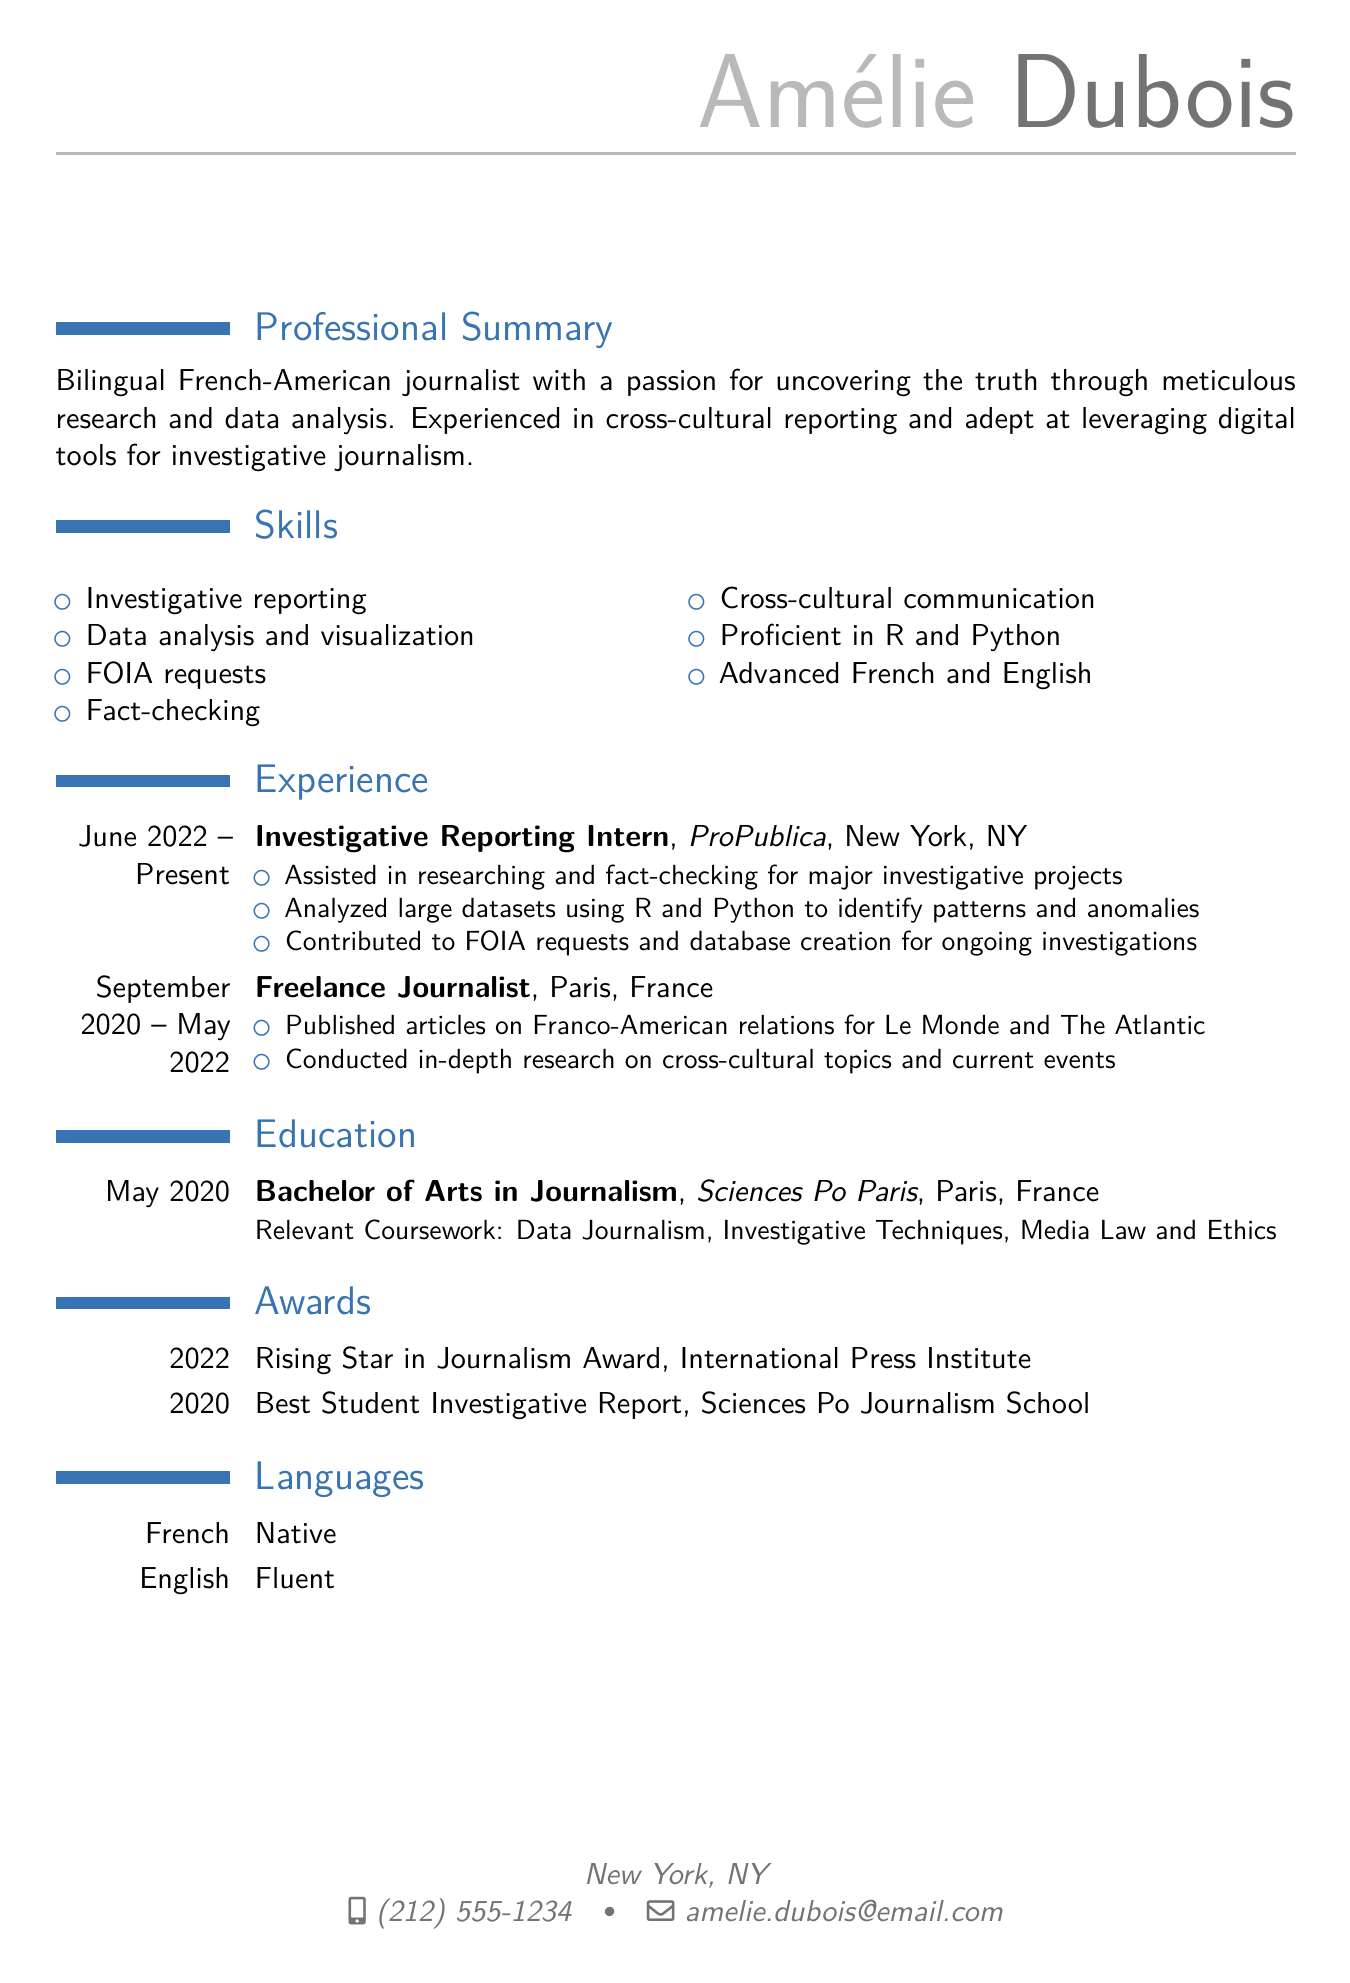What is Amélie Dubois's email address? The email address is provided in the personal information section of the resume.
Answer: amelie.dubois@email.com What role does Amélie currently hold? The resume states that Amélie is an Investigative Reporting Intern at ProPublica.
Answer: Investigative Reporting Intern In which city is ProPublica located? The location of ProPublica is listed under the experience section.
Answer: New York, NY Which language is mentioned as Amélie's native language? The languages section specifies her native language.
Answer: French What award did Amélie receive in 2022? The awards section lists the recognized achievement for the year 2022.
Answer: Rising Star in Journalism Award How many years did Amélie work as a Freelance Journalist? The dates in the experience section indicate the duration of her freelance work.
Answer: 1 year and 8 months What is the degree Amélie holds? The education section states the degree earned by Amélie.
Answer: Bachelor of Arts in Journalism Which programming languages is Amélie proficient in? Her skills section includes specific programming languages.
Answer: R and Python What topic did Amélie focus on while publishing articles? The experience section highlights the subject matter she reported on.
Answer: Franco-American relations 